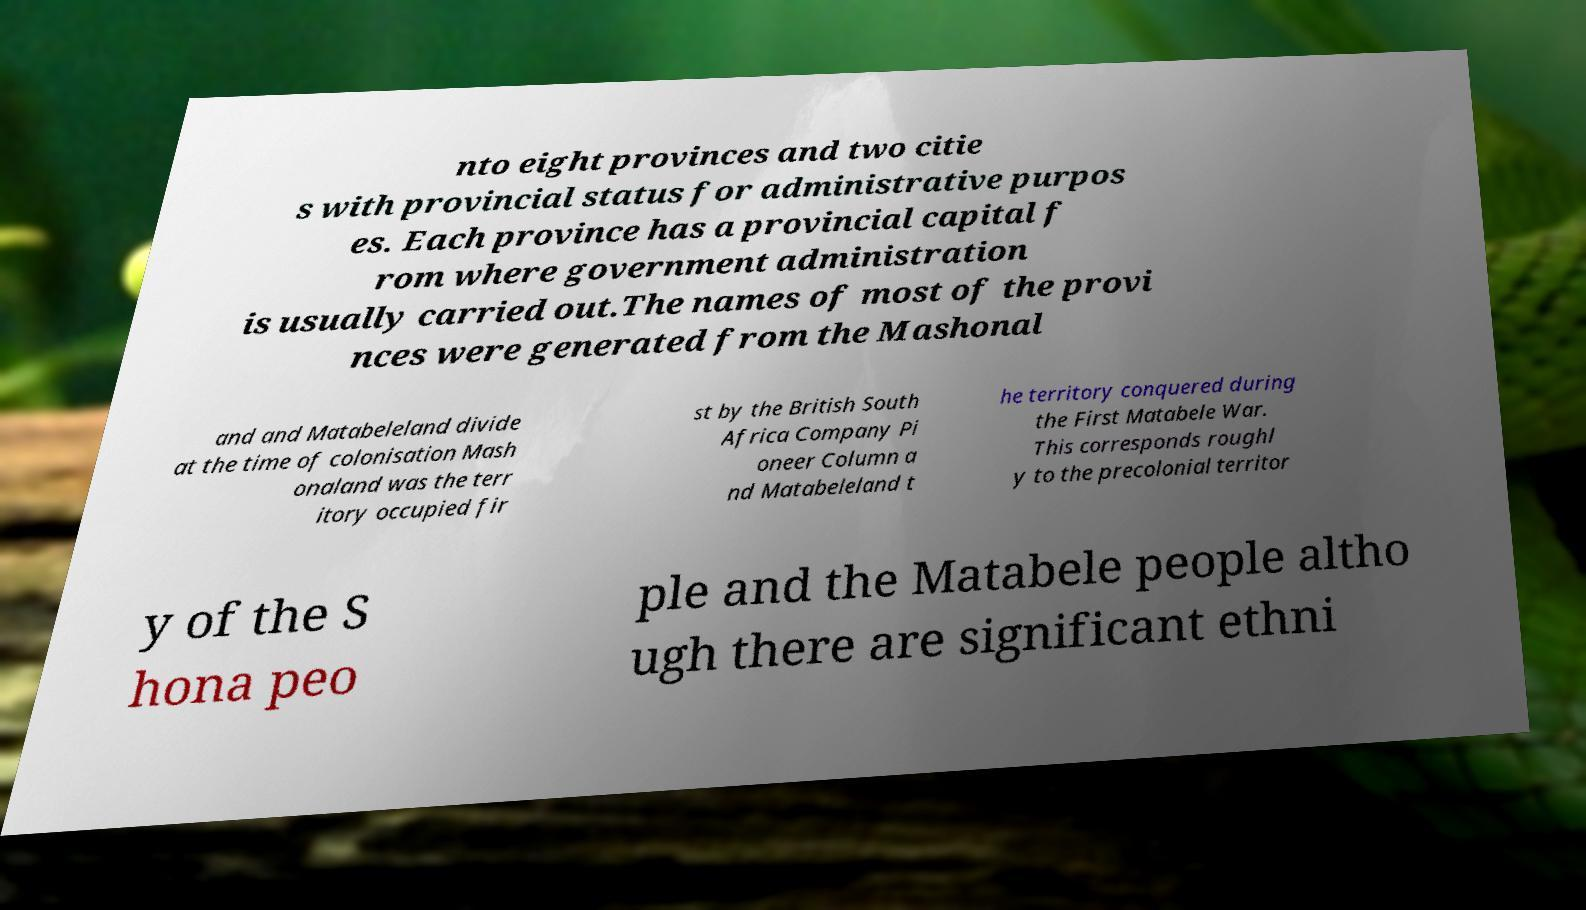I need the written content from this picture converted into text. Can you do that? nto eight provinces and two citie s with provincial status for administrative purpos es. Each province has a provincial capital f rom where government administration is usually carried out.The names of most of the provi nces were generated from the Mashonal and and Matabeleland divide at the time of colonisation Mash onaland was the terr itory occupied fir st by the British South Africa Company Pi oneer Column a nd Matabeleland t he territory conquered during the First Matabele War. This corresponds roughl y to the precolonial territor y of the S hona peo ple and the Matabele people altho ugh there are significant ethni 